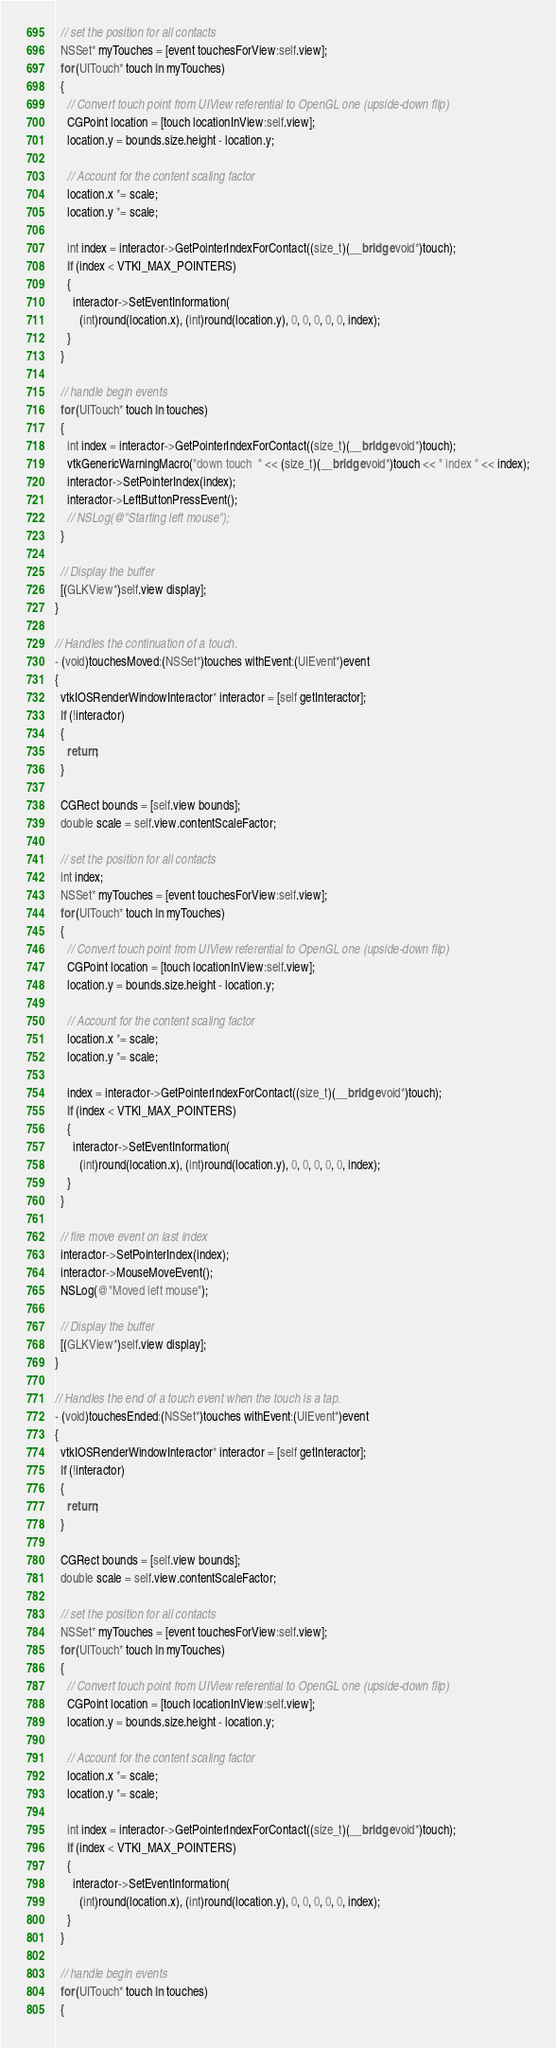<code> <loc_0><loc_0><loc_500><loc_500><_ObjectiveC_>
  // set the position for all contacts
  NSSet* myTouches = [event touchesForView:self.view];
  for (UITouch* touch in myTouches)
  {
    // Convert touch point from UIView referential to OpenGL one (upside-down flip)
    CGPoint location = [touch locationInView:self.view];
    location.y = bounds.size.height - location.y;

    // Account for the content scaling factor
    location.x *= scale;
    location.y *= scale;

    int index = interactor->GetPointerIndexForContact((size_t)(__bridge void*)touch);
    if (index < VTKI_MAX_POINTERS)
    {
      interactor->SetEventInformation(
        (int)round(location.x), (int)round(location.y), 0, 0, 0, 0, 0, index);
    }
  }

  // handle begin events
  for (UITouch* touch in touches)
  {
    int index = interactor->GetPointerIndexForContact((size_t)(__bridge void*)touch);
    vtkGenericWarningMacro("down touch  " << (size_t)(__bridge void*)touch << " index " << index);
    interactor->SetPointerIndex(index);
    interactor->LeftButtonPressEvent();
    // NSLog(@"Starting left mouse");
  }

  // Display the buffer
  [(GLKView*)self.view display];
}

// Handles the continuation of a touch.
- (void)touchesMoved:(NSSet*)touches withEvent:(UIEvent*)event
{
  vtkIOSRenderWindowInteractor* interactor = [self getInteractor];
  if (!interactor)
  {
    return;
  }

  CGRect bounds = [self.view bounds];
  double scale = self.view.contentScaleFactor;

  // set the position for all contacts
  int index;
  NSSet* myTouches = [event touchesForView:self.view];
  for (UITouch* touch in myTouches)
  {
    // Convert touch point from UIView referential to OpenGL one (upside-down flip)
    CGPoint location = [touch locationInView:self.view];
    location.y = bounds.size.height - location.y;

    // Account for the content scaling factor
    location.x *= scale;
    location.y *= scale;

    index = interactor->GetPointerIndexForContact((size_t)(__bridge void*)touch);
    if (index < VTKI_MAX_POINTERS)
    {
      interactor->SetEventInformation(
        (int)round(location.x), (int)round(location.y), 0, 0, 0, 0, 0, index);
    }
  }

  // fire move event on last index
  interactor->SetPointerIndex(index);
  interactor->MouseMoveEvent();
  NSLog(@"Moved left mouse");

  // Display the buffer
  [(GLKView*)self.view display];
}

// Handles the end of a touch event when the touch is a tap.
- (void)touchesEnded:(NSSet*)touches withEvent:(UIEvent*)event
{
  vtkIOSRenderWindowInteractor* interactor = [self getInteractor];
  if (!interactor)
  {
    return;
  }

  CGRect bounds = [self.view bounds];
  double scale = self.view.contentScaleFactor;

  // set the position for all contacts
  NSSet* myTouches = [event touchesForView:self.view];
  for (UITouch* touch in myTouches)
  {
    // Convert touch point from UIView referential to OpenGL one (upside-down flip)
    CGPoint location = [touch locationInView:self.view];
    location.y = bounds.size.height - location.y;

    // Account for the content scaling factor
    location.x *= scale;
    location.y *= scale;

    int index = interactor->GetPointerIndexForContact((size_t)(__bridge void*)touch);
    if (index < VTKI_MAX_POINTERS)
    {
      interactor->SetEventInformation(
        (int)round(location.x), (int)round(location.y), 0, 0, 0, 0, 0, index);
    }
  }

  // handle begin events
  for (UITouch* touch in touches)
  {</code> 